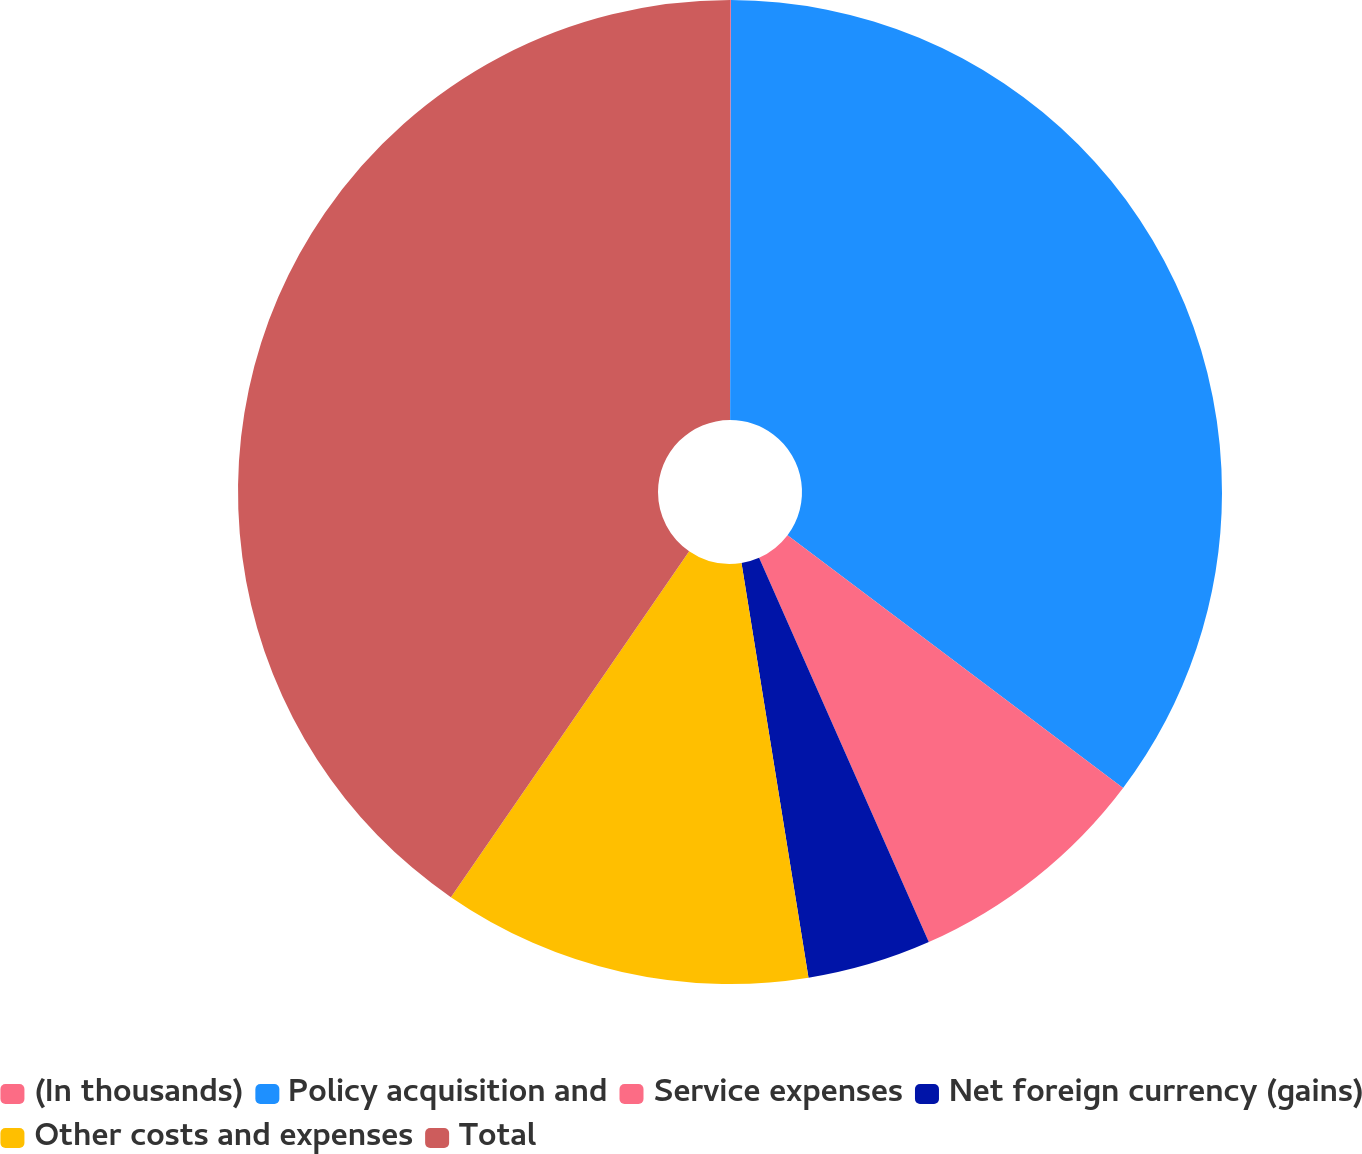<chart> <loc_0><loc_0><loc_500><loc_500><pie_chart><fcel>(In thousands)<fcel>Policy acquisition and<fcel>Service expenses<fcel>Net foreign currency (gains)<fcel>Other costs and expenses<fcel>Total<nl><fcel>0.03%<fcel>35.24%<fcel>8.11%<fcel>4.07%<fcel>12.15%<fcel>40.4%<nl></chart> 